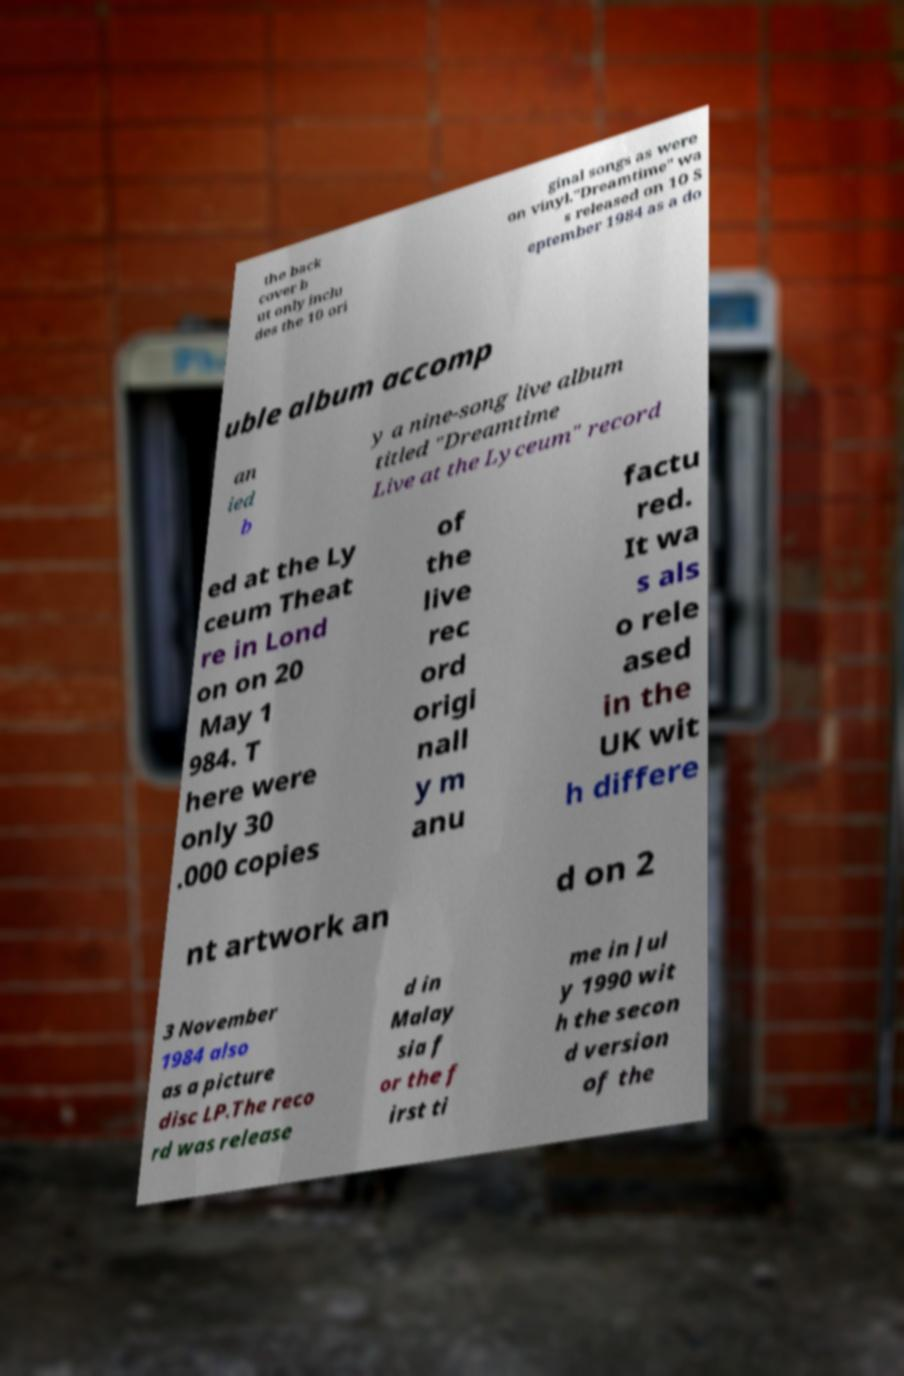Could you assist in decoding the text presented in this image and type it out clearly? the back cover b ut only inclu des the 10 ori ginal songs as were on vinyl."Dreamtime" wa s released on 10 S eptember 1984 as a do uble album accomp an ied b y a nine-song live album titled "Dreamtime Live at the Lyceum" record ed at the Ly ceum Theat re in Lond on on 20 May 1 984. T here were only 30 .000 copies of the live rec ord origi nall y m anu factu red. It wa s als o rele ased in the UK wit h differe nt artwork an d on 2 3 November 1984 also as a picture disc LP.The reco rd was release d in Malay sia f or the f irst ti me in Jul y 1990 wit h the secon d version of the 